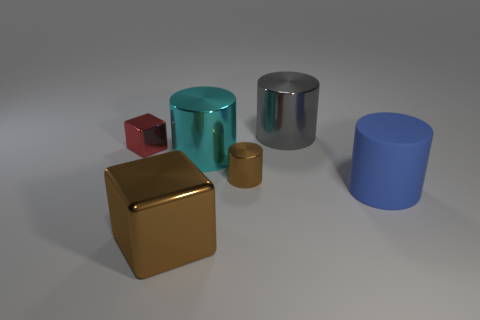Add 3 cyan metallic things. How many objects exist? 9 Subtract all blocks. How many objects are left? 4 Add 3 cubes. How many cubes exist? 5 Subtract 0 green spheres. How many objects are left? 6 Subtract all tiny cyan balls. Subtract all shiny objects. How many objects are left? 1 Add 5 brown blocks. How many brown blocks are left? 6 